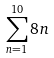<formula> <loc_0><loc_0><loc_500><loc_500>\sum _ { n = 1 } ^ { 1 0 } 8 n</formula> 